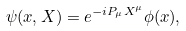Convert formula to latex. <formula><loc_0><loc_0><loc_500><loc_500>\psi ( x , X ) = e ^ { - i P _ { \mu } X ^ { \mu } } \phi ( x ) ,</formula> 